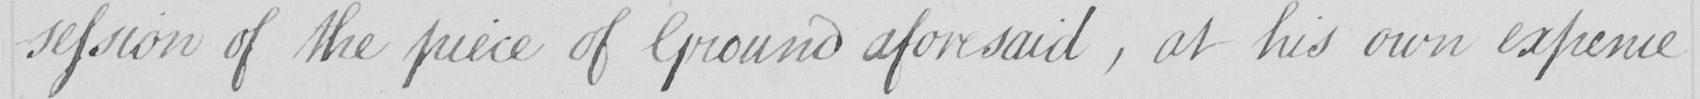Please provide the text content of this handwritten line. -session of the piece of Ground aforesaid  , at his own expence 